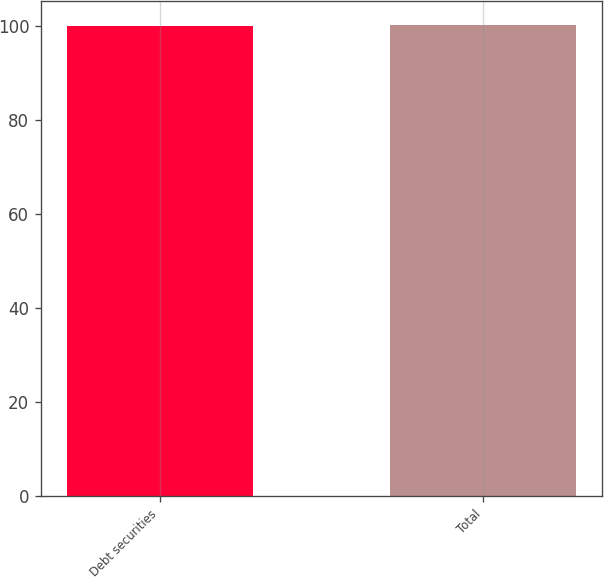<chart> <loc_0><loc_0><loc_500><loc_500><bar_chart><fcel>Debt securities<fcel>Total<nl><fcel>100<fcel>100.1<nl></chart> 